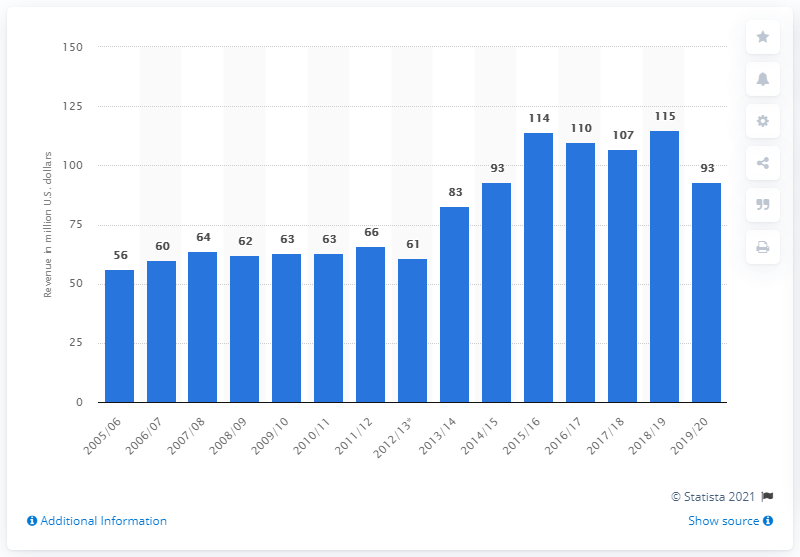Identify some key points in this picture. In the 2019/2020 season, the New York Islanders generated a revenue of 93... 